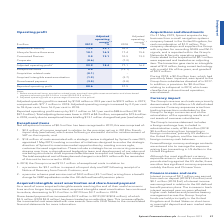According to Spirent Communications Plc's financial document, What was the adjusted operating margin in 2018? According to the financial document, 16.2 per cent. The relevant text states: "increased by 2.2 per cent to 18.4 per cent, from 16.2 per cent in 2018...." Also, What was the reported operating profit in 2019? According to the financial document, $88.6 million. The relevant text states: "profit was up by $31.1 million or 54.1 per cent to $88.6 million (2018 $57.5 million). Total adjusting items were lower in 2019 at $4.3 million, compared to $19.6 mi..." Also, What were the items factored into the adjusted operating profit to derive the reported operating profit in 2019? The document contains multiple relevant values: Exceptional items, Acquisition related costs, Acquired intangible asset amortisation, Share-based payment. From the document: "Acquisition related costs (0.1) – Exceptional items 0.5 (13.1) Acquired intangible asset amortisation (1.2) (3.7) Share-based payment (3.5) (2.8)..." Additionally, In which year was the adjusted operating margin for Lifecycle Service Assurance larger? According to the financial document, 2019. The relevant text states: "37 Spirent Communications plc Annual Report 2019..." Also, can you calculate: What was the change in operating profit under Networks & Security? Based on the calculation: 73.9-56.4, the result is 17.5 (in millions). This is based on the information: "Networks & Security 73.9 23.1 56.4 19.8 Networks & Security 73.9 23.1 56.4 19.8..." The key data points involved are: 56.4, 73.9. Also, can you calculate: What was the percentage change in operating profit under Networks & Security? To answer this question, I need to perform calculations using the financial data. The calculation is: (73.9-56.4)/56.4, which equals 31.03 (percentage). This is based on the information: "Networks & Security 73.9 23.1 56.4 19.8 Networks & Security 73.9 23.1 56.4 19.8..." The key data points involved are: 56.4, 73.9. 